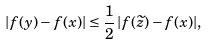Convert formula to latex. <formula><loc_0><loc_0><loc_500><loc_500>| f ( y ) - f ( x ) | \leq \frac { 1 } { 2 } \, | f ( \widetilde { z } ) - f ( x ) | ,</formula> 